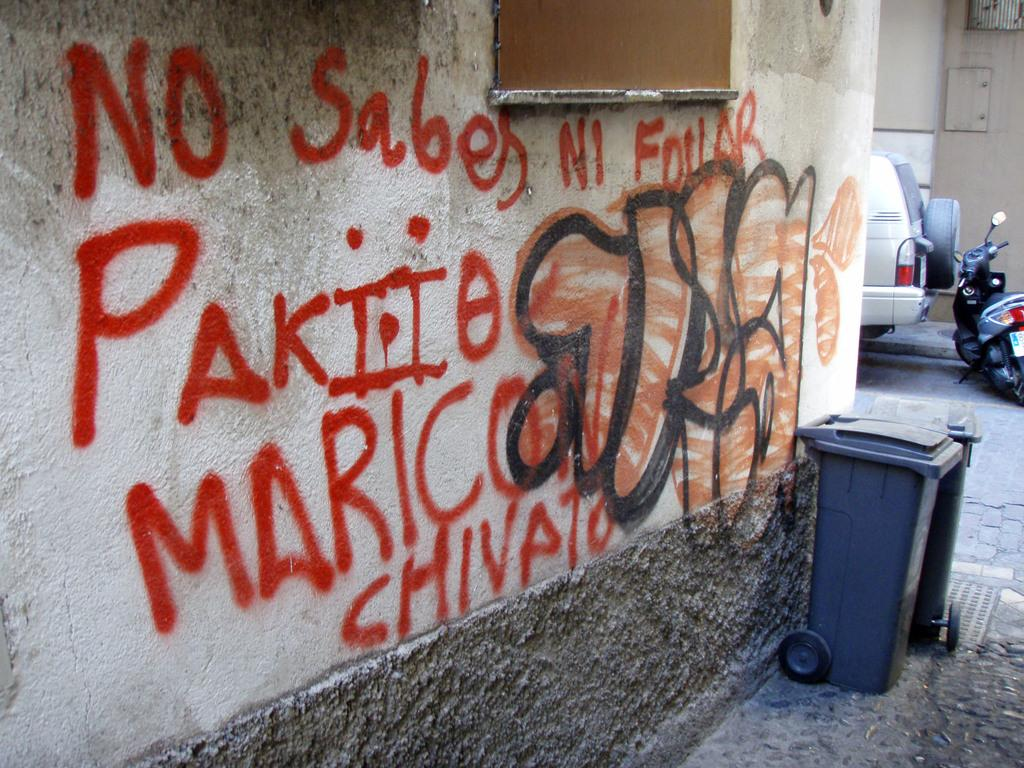Provide a one-sentence caption for the provided image. graffiti on a wall saying NO SABES Ni Fourar. 